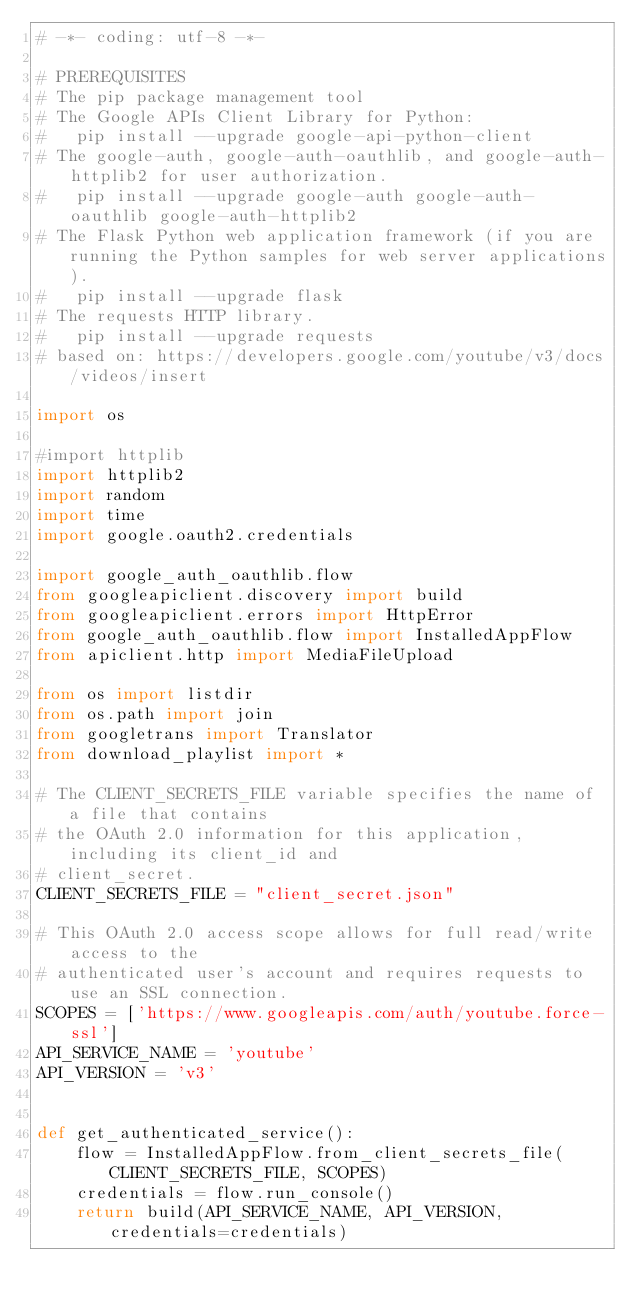Convert code to text. <code><loc_0><loc_0><loc_500><loc_500><_Python_># -*- coding: utf-8 -*-

# PREREQUISITES
# The pip package management tool
# The Google APIs Client Library for Python:
#   pip install --upgrade google-api-python-client
# The google-auth, google-auth-oauthlib, and google-auth-httplib2 for user authorization.
#   pip install --upgrade google-auth google-auth-oauthlib google-auth-httplib2
# The Flask Python web application framework (if you are running the Python samples for web server applications).
#   pip install --upgrade flask
# The requests HTTP library.
#   pip install --upgrade requests
# based on: https://developers.google.com/youtube/v3/docs/videos/insert

import os

#import httplib
import httplib2
import random
import time
import google.oauth2.credentials

import google_auth_oauthlib.flow
from googleapiclient.discovery import build
from googleapiclient.errors import HttpError
from google_auth_oauthlib.flow import InstalledAppFlow
from apiclient.http import MediaFileUpload

from os import listdir
from os.path import join
from googletrans import Translator
from download_playlist import *

# The CLIENT_SECRETS_FILE variable specifies the name of a file that contains
# the OAuth 2.0 information for this application, including its client_id and
# client_secret.
CLIENT_SECRETS_FILE = "client_secret.json"

# This OAuth 2.0 access scope allows for full read/write access to the
# authenticated user's account and requires requests to use an SSL connection.
SCOPES = ['https://www.googleapis.com/auth/youtube.force-ssl']
API_SERVICE_NAME = 'youtube'
API_VERSION = 'v3'


def get_authenticated_service():
    flow = InstalledAppFlow.from_client_secrets_file(CLIENT_SECRETS_FILE, SCOPES)
    credentials = flow.run_console()
    return build(API_SERVICE_NAME, API_VERSION, credentials=credentials)</code> 